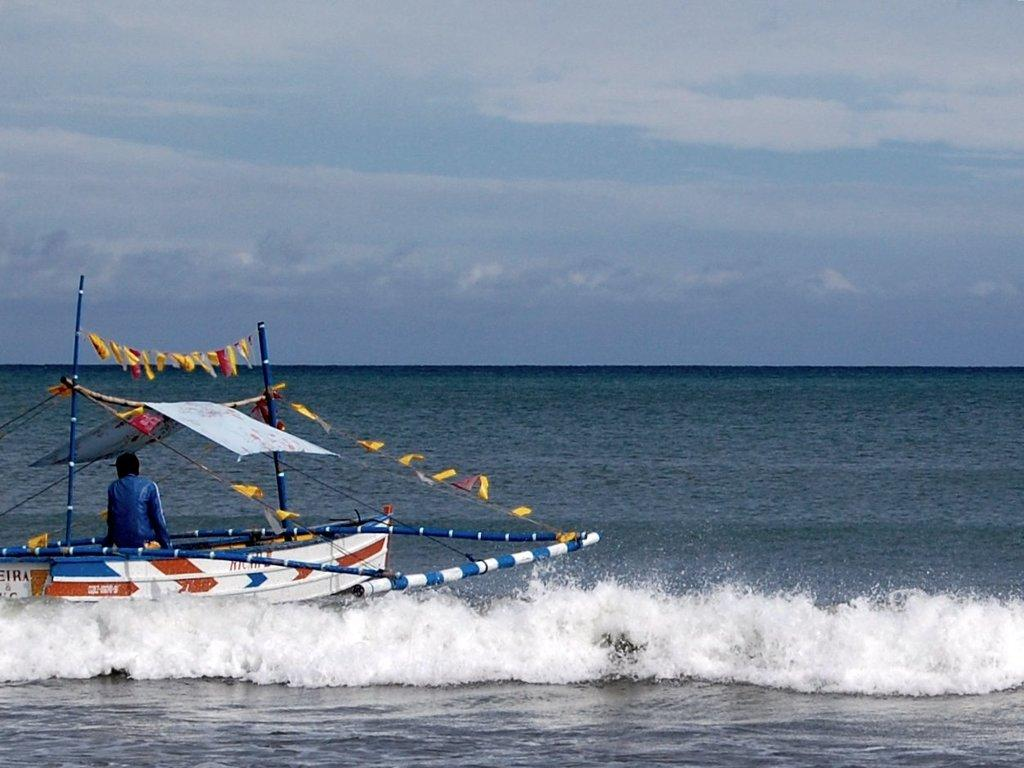What is the person in the image doing? There is a person sitting on a boat in the image. What can be seen below the boat in the image? There is water visible at the bottom of the image. What is visible above the boat in the image? The sky is visible at the top of the image. What type of chess piece is floating on the water in the image? There is no chess piece visible in the image; it only features a person sitting on a boat. 